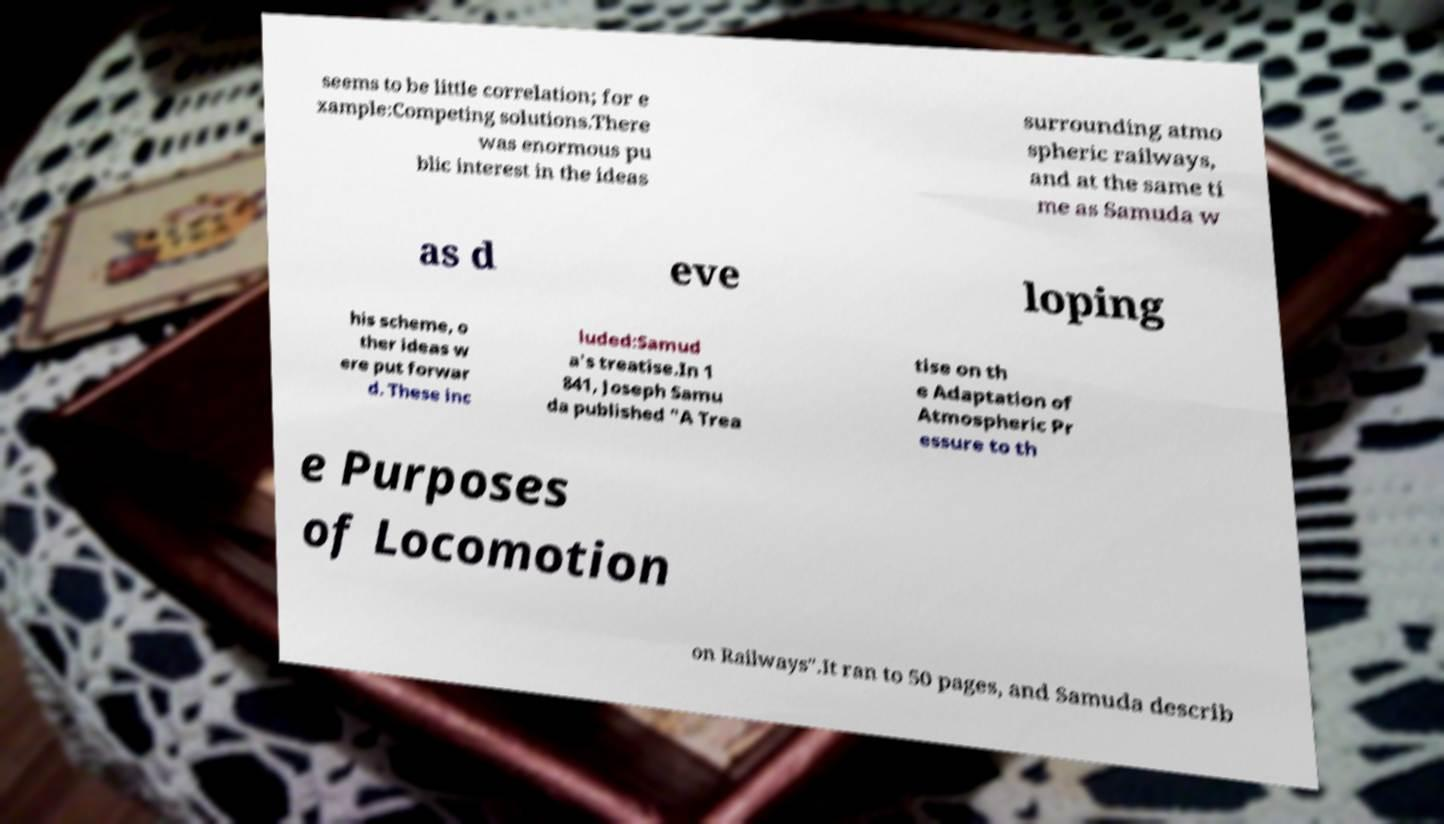For documentation purposes, I need the text within this image transcribed. Could you provide that? seems to be little correlation; for e xample:Competing solutions.There was enormous pu blic interest in the ideas surrounding atmo spheric railways, and at the same ti me as Samuda w as d eve loping his scheme, o ther ideas w ere put forwar d. These inc luded:Samud a's treatise.In 1 841, Joseph Samu da published "A Trea tise on th e Adaptation of Atmospheric Pr essure to th e Purposes of Locomotion on Railways".It ran to 50 pages, and Samuda describ 